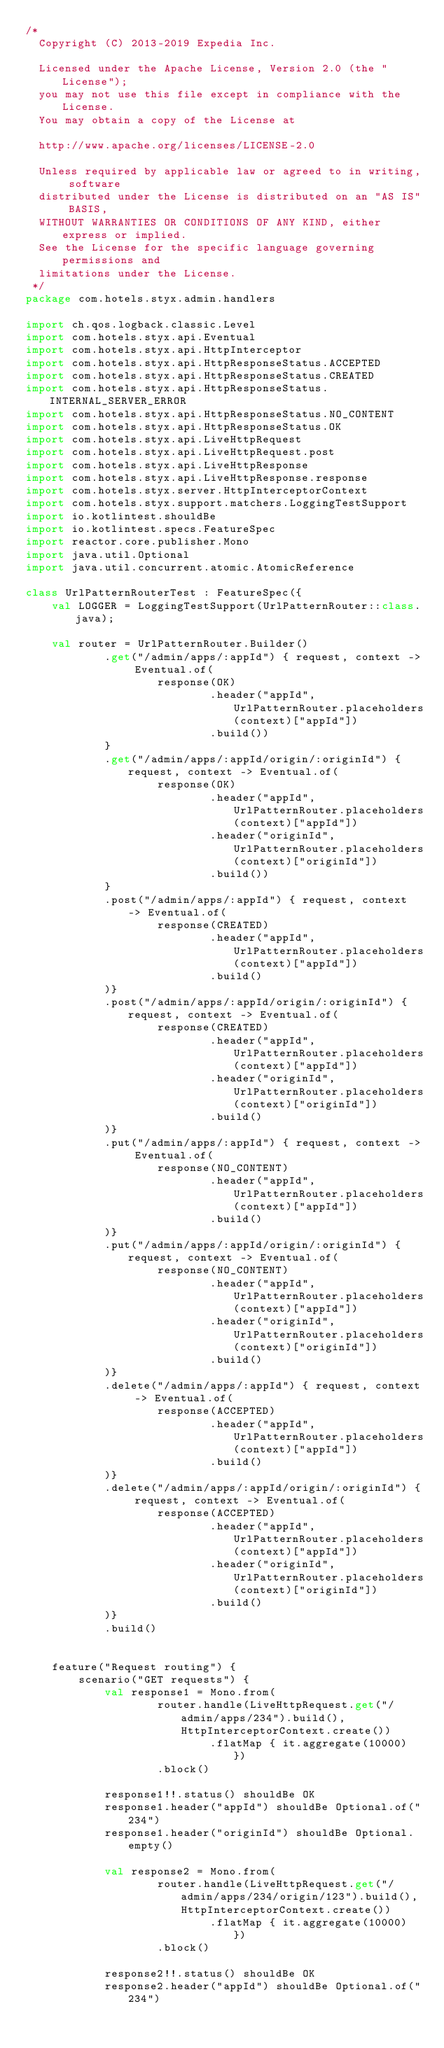<code> <loc_0><loc_0><loc_500><loc_500><_Kotlin_>/*
  Copyright (C) 2013-2019 Expedia Inc.

  Licensed under the Apache License, Version 2.0 (the "License");
  you may not use this file except in compliance with the License.
  You may obtain a copy of the License at

  http://www.apache.org/licenses/LICENSE-2.0

  Unless required by applicable law or agreed to in writing, software
  distributed under the License is distributed on an "AS IS" BASIS,
  WITHOUT WARRANTIES OR CONDITIONS OF ANY KIND, either express or implied.
  See the License for the specific language governing permissions and
  limitations under the License.
 */
package com.hotels.styx.admin.handlers

import ch.qos.logback.classic.Level
import com.hotels.styx.api.Eventual
import com.hotels.styx.api.HttpInterceptor
import com.hotels.styx.api.HttpResponseStatus.ACCEPTED
import com.hotels.styx.api.HttpResponseStatus.CREATED
import com.hotels.styx.api.HttpResponseStatus.INTERNAL_SERVER_ERROR
import com.hotels.styx.api.HttpResponseStatus.NO_CONTENT
import com.hotels.styx.api.HttpResponseStatus.OK
import com.hotels.styx.api.LiveHttpRequest
import com.hotels.styx.api.LiveHttpRequest.post
import com.hotels.styx.api.LiveHttpResponse
import com.hotels.styx.api.LiveHttpResponse.response
import com.hotels.styx.server.HttpInterceptorContext
import com.hotels.styx.support.matchers.LoggingTestSupport
import io.kotlintest.shouldBe
import io.kotlintest.specs.FeatureSpec
import reactor.core.publisher.Mono
import java.util.Optional
import java.util.concurrent.atomic.AtomicReference

class UrlPatternRouterTest : FeatureSpec({
    val LOGGER = LoggingTestSupport(UrlPatternRouter::class.java);

    val router = UrlPatternRouter.Builder()
            .get("/admin/apps/:appId") { request, context -> Eventual.of(
                    response(OK)
                            .header("appId", UrlPatternRouter.placeholders(context)["appId"])
                            .build())
            }
            .get("/admin/apps/:appId/origin/:originId") { request, context -> Eventual.of(
                    response(OK)
                            .header("appId", UrlPatternRouter.placeholders(context)["appId"])
                            .header("originId", UrlPatternRouter.placeholders(context)["originId"])
                            .build())
            }
            .post("/admin/apps/:appId") { request, context -> Eventual.of(
                    response(CREATED)
                            .header("appId", UrlPatternRouter.placeholders(context)["appId"])
                            .build()
            )}
            .post("/admin/apps/:appId/origin/:originId") { request, context -> Eventual.of(
                    response(CREATED)
                            .header("appId", UrlPatternRouter.placeholders(context)["appId"])
                            .header("originId", UrlPatternRouter.placeholders(context)["originId"])
                            .build()
            )}
            .put("/admin/apps/:appId") { request, context -> Eventual.of(
                    response(NO_CONTENT)
                            .header("appId", UrlPatternRouter.placeholders(context)["appId"])
                            .build()
            )}
            .put("/admin/apps/:appId/origin/:originId") { request, context -> Eventual.of(
                    response(NO_CONTENT)
                            .header("appId", UrlPatternRouter.placeholders(context)["appId"])
                            .header("originId", UrlPatternRouter.placeholders(context)["originId"])
                            .build()
            )}
            .delete("/admin/apps/:appId") { request, context -> Eventual.of(
                    response(ACCEPTED)
                            .header("appId", UrlPatternRouter.placeholders(context)["appId"])
                            .build()
            )}
            .delete("/admin/apps/:appId/origin/:originId") { request, context -> Eventual.of(
                    response(ACCEPTED)
                            .header("appId", UrlPatternRouter.placeholders(context)["appId"])
                            .header("originId", UrlPatternRouter.placeholders(context)["originId"])
                            .build()
            )}
            .build()


    feature("Request routing") {
        scenario("GET requests") {
            val response1 = Mono.from(
                    router.handle(LiveHttpRequest.get("/admin/apps/234").build(), HttpInterceptorContext.create())
                            .flatMap { it.aggregate(10000) })
                    .block()

            response1!!.status() shouldBe OK
            response1.header("appId") shouldBe Optional.of("234")
            response1.header("originId") shouldBe Optional.empty()

            val response2 = Mono.from(
                    router.handle(LiveHttpRequest.get("/admin/apps/234/origin/123").build(), HttpInterceptorContext.create())
                            .flatMap { it.aggregate(10000) })
                    .block()

            response2!!.status() shouldBe OK
            response2.header("appId") shouldBe Optional.of("234")</code> 